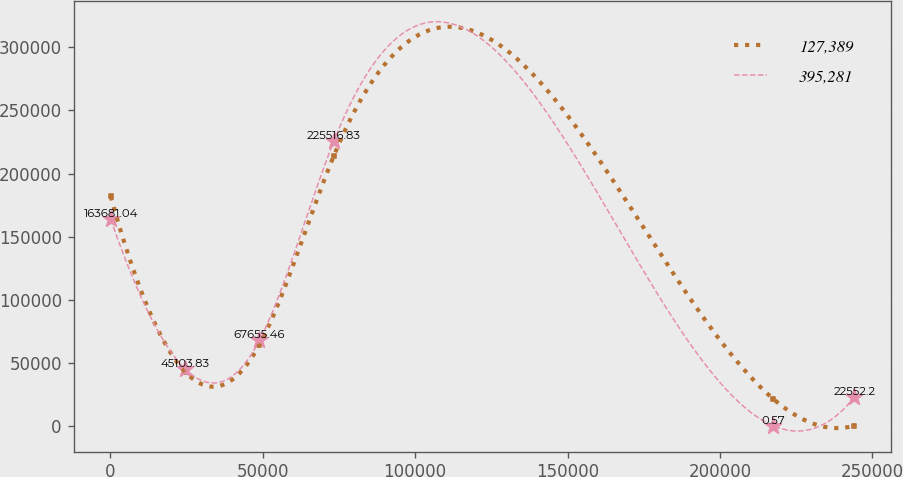Convert chart. <chart><loc_0><loc_0><loc_500><loc_500><line_chart><ecel><fcel>127,389<fcel>395,281<nl><fcel>137.02<fcel>181848<fcel>163681<nl><fcel>24528.4<fcel>42789<fcel>45103.8<nl><fcel>48919.8<fcel>64182.6<fcel>67655.5<nl><fcel>73311.2<fcel>213937<fcel>225517<nl><fcel>217405<fcel>21395.5<fcel>0.57<nl><fcel>244051<fcel>1.96<fcel>22552.2<nl></chart> 